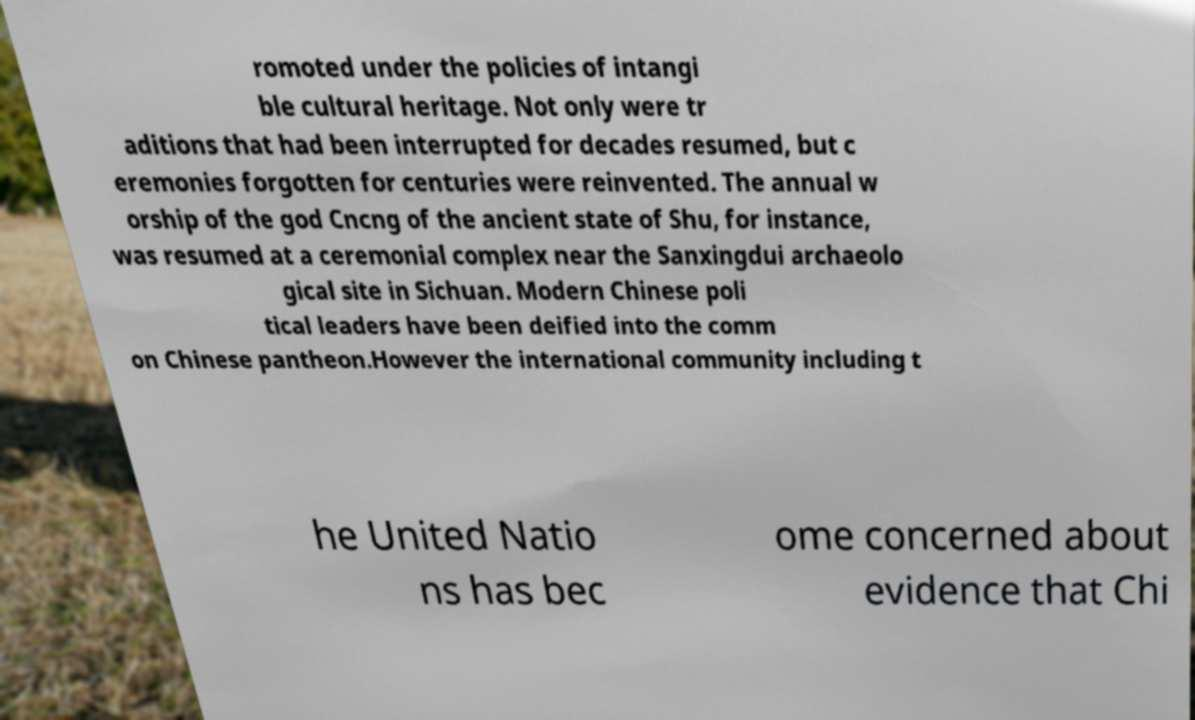What messages or text are displayed in this image? I need them in a readable, typed format. romoted under the policies of intangi ble cultural heritage. Not only were tr aditions that had been interrupted for decades resumed, but c eremonies forgotten for centuries were reinvented. The annual w orship of the god Cncng of the ancient state of Shu, for instance, was resumed at a ceremonial complex near the Sanxingdui archaeolo gical site in Sichuan. Modern Chinese poli tical leaders have been deified into the comm on Chinese pantheon.However the international community including t he United Natio ns has bec ome concerned about evidence that Chi 